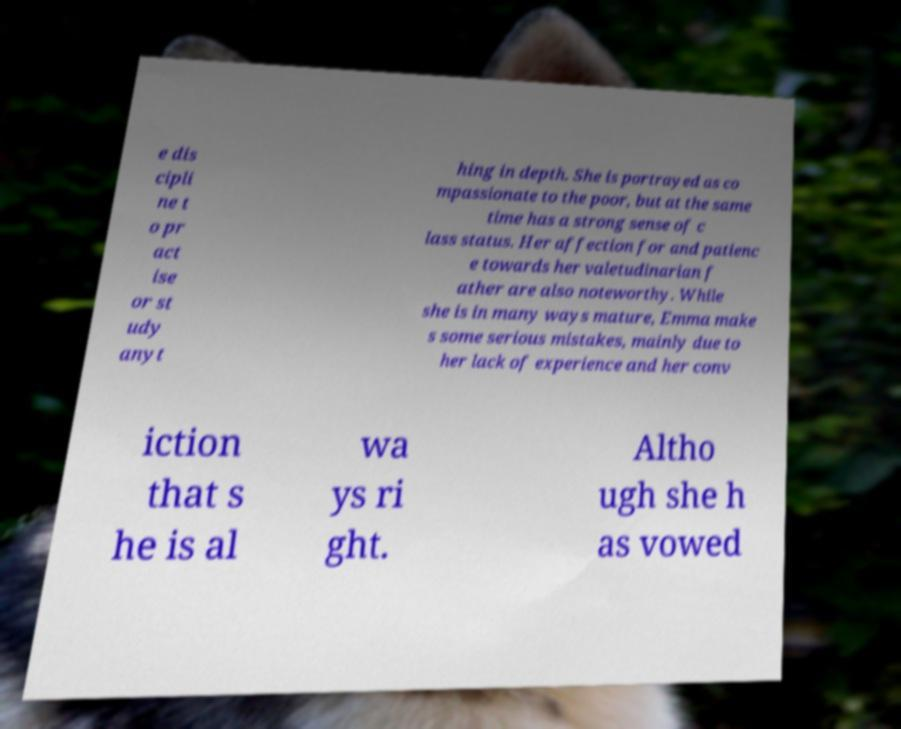Could you extract and type out the text from this image? e dis cipli ne t o pr act ise or st udy anyt hing in depth. She is portrayed as co mpassionate to the poor, but at the same time has a strong sense of c lass status. Her affection for and patienc e towards her valetudinarian f ather are also noteworthy. While she is in many ways mature, Emma make s some serious mistakes, mainly due to her lack of experience and her conv iction that s he is al wa ys ri ght. Altho ugh she h as vowed 